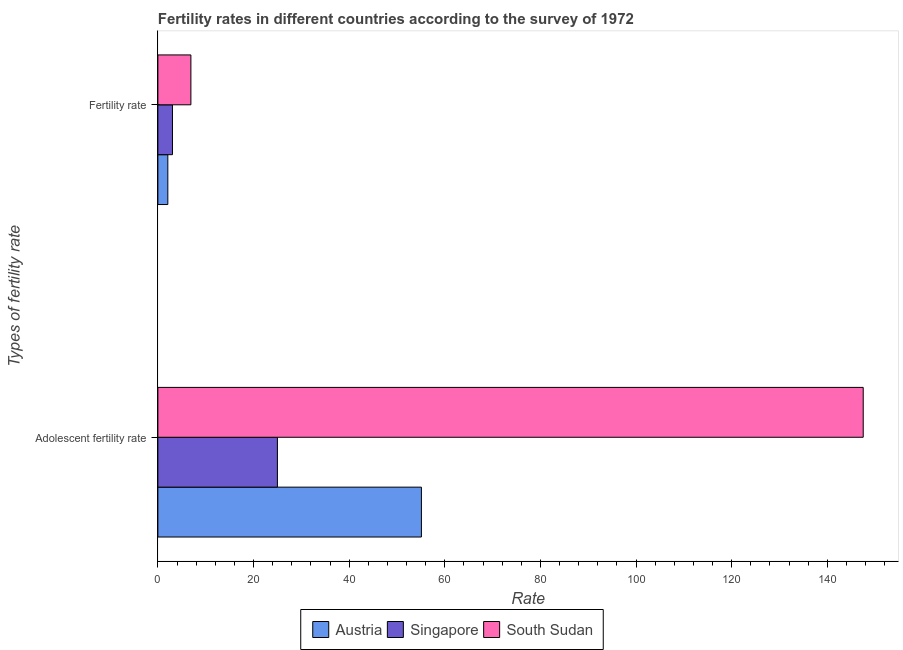How many groups of bars are there?
Ensure brevity in your answer.  2. Are the number of bars per tick equal to the number of legend labels?
Ensure brevity in your answer.  Yes. How many bars are there on the 1st tick from the top?
Provide a succinct answer. 3. What is the label of the 2nd group of bars from the top?
Provide a succinct answer. Adolescent fertility rate. What is the adolescent fertility rate in Austria?
Offer a very short reply. 55.12. Across all countries, what is the maximum adolescent fertility rate?
Provide a succinct answer. 147.52. Across all countries, what is the minimum fertility rate?
Your answer should be very brief. 2.08. In which country was the adolescent fertility rate maximum?
Provide a short and direct response. South Sudan. In which country was the adolescent fertility rate minimum?
Offer a very short reply. Singapore. What is the total fertility rate in the graph?
Your response must be concise. 12.03. What is the difference between the fertility rate in Austria and that in Singapore?
Your response must be concise. -0.97. What is the difference between the fertility rate in South Sudan and the adolescent fertility rate in Singapore?
Give a very brief answer. -18.09. What is the average adolescent fertility rate per country?
Your answer should be compact. 75.88. What is the difference between the adolescent fertility rate and fertility rate in South Sudan?
Provide a succinct answer. 140.62. In how many countries, is the adolescent fertility rate greater than 32 ?
Offer a very short reply. 2. What is the ratio of the adolescent fertility rate in Austria to that in South Sudan?
Provide a succinct answer. 0.37. How many bars are there?
Offer a very short reply. 6. Are all the bars in the graph horizontal?
Offer a very short reply. Yes. How many countries are there in the graph?
Your answer should be very brief. 3. What is the difference between two consecutive major ticks on the X-axis?
Provide a short and direct response. 20. Are the values on the major ticks of X-axis written in scientific E-notation?
Provide a succinct answer. No. How many legend labels are there?
Provide a short and direct response. 3. What is the title of the graph?
Give a very brief answer. Fertility rates in different countries according to the survey of 1972. Does "Philippines" appear as one of the legend labels in the graph?
Your answer should be compact. No. What is the label or title of the X-axis?
Provide a succinct answer. Rate. What is the label or title of the Y-axis?
Ensure brevity in your answer.  Types of fertility rate. What is the Rate of Austria in Adolescent fertility rate?
Keep it short and to the point. 55.12. What is the Rate of Singapore in Adolescent fertility rate?
Offer a very short reply. 25. What is the Rate of South Sudan in Adolescent fertility rate?
Keep it short and to the point. 147.52. What is the Rate of Austria in Fertility rate?
Provide a succinct answer. 2.08. What is the Rate of Singapore in Fertility rate?
Ensure brevity in your answer.  3.05. What is the Rate in South Sudan in Fertility rate?
Make the answer very short. 6.9. Across all Types of fertility rate, what is the maximum Rate in Austria?
Keep it short and to the point. 55.12. Across all Types of fertility rate, what is the maximum Rate in Singapore?
Offer a very short reply. 25. Across all Types of fertility rate, what is the maximum Rate in South Sudan?
Provide a short and direct response. 147.52. Across all Types of fertility rate, what is the minimum Rate of Austria?
Your response must be concise. 2.08. Across all Types of fertility rate, what is the minimum Rate in Singapore?
Ensure brevity in your answer.  3.05. Across all Types of fertility rate, what is the minimum Rate of South Sudan?
Keep it short and to the point. 6.9. What is the total Rate in Austria in the graph?
Your answer should be very brief. 57.2. What is the total Rate in Singapore in the graph?
Give a very brief answer. 28.05. What is the total Rate of South Sudan in the graph?
Give a very brief answer. 154.43. What is the difference between the Rate of Austria in Adolescent fertility rate and that in Fertility rate?
Provide a short and direct response. 53.03. What is the difference between the Rate of Singapore in Adolescent fertility rate and that in Fertility rate?
Provide a succinct answer. 21.95. What is the difference between the Rate of South Sudan in Adolescent fertility rate and that in Fertility rate?
Your answer should be compact. 140.62. What is the difference between the Rate in Austria in Adolescent fertility rate and the Rate in Singapore in Fertility rate?
Provide a succinct answer. 52.07. What is the difference between the Rate in Austria in Adolescent fertility rate and the Rate in South Sudan in Fertility rate?
Ensure brevity in your answer.  48.21. What is the difference between the Rate of Singapore in Adolescent fertility rate and the Rate of South Sudan in Fertility rate?
Give a very brief answer. 18.09. What is the average Rate in Austria per Types of fertility rate?
Your answer should be very brief. 28.6. What is the average Rate of Singapore per Types of fertility rate?
Your answer should be very brief. 14.02. What is the average Rate of South Sudan per Types of fertility rate?
Give a very brief answer. 77.21. What is the difference between the Rate in Austria and Rate in Singapore in Adolescent fertility rate?
Provide a short and direct response. 30.12. What is the difference between the Rate in Austria and Rate in South Sudan in Adolescent fertility rate?
Provide a short and direct response. -92.41. What is the difference between the Rate in Singapore and Rate in South Sudan in Adolescent fertility rate?
Keep it short and to the point. -122.53. What is the difference between the Rate in Austria and Rate in Singapore in Fertility rate?
Keep it short and to the point. -0.97. What is the difference between the Rate in Austria and Rate in South Sudan in Fertility rate?
Keep it short and to the point. -4.82. What is the difference between the Rate in Singapore and Rate in South Sudan in Fertility rate?
Keep it short and to the point. -3.85. What is the ratio of the Rate of Austria in Adolescent fertility rate to that in Fertility rate?
Ensure brevity in your answer.  26.5. What is the ratio of the Rate in Singapore in Adolescent fertility rate to that in Fertility rate?
Keep it short and to the point. 8.2. What is the ratio of the Rate of South Sudan in Adolescent fertility rate to that in Fertility rate?
Provide a short and direct response. 21.37. What is the difference between the highest and the second highest Rate in Austria?
Your response must be concise. 53.03. What is the difference between the highest and the second highest Rate in Singapore?
Ensure brevity in your answer.  21.95. What is the difference between the highest and the second highest Rate of South Sudan?
Offer a terse response. 140.62. What is the difference between the highest and the lowest Rate of Austria?
Provide a short and direct response. 53.03. What is the difference between the highest and the lowest Rate in Singapore?
Make the answer very short. 21.95. What is the difference between the highest and the lowest Rate in South Sudan?
Give a very brief answer. 140.62. 